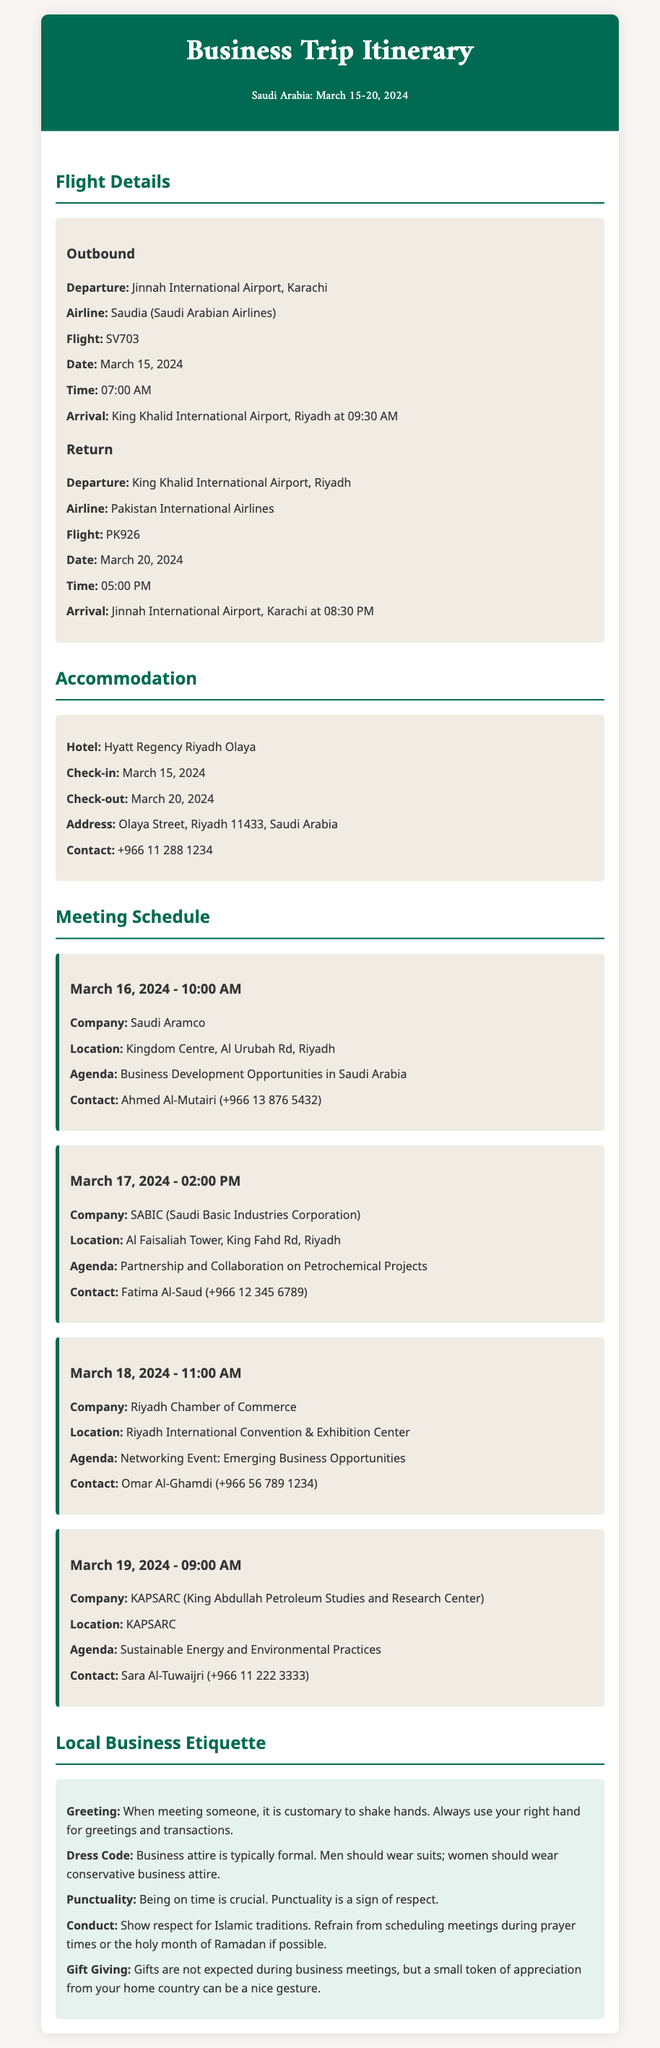What is the departure airport for the outbound flight? The departure airport is specified as Jinnah International Airport, Karachi in the flight details.
Answer: Jinnah International Airport, Karachi What is the check-in date for the accommodation? The check-in date is given under the accommodation section of the document.
Answer: March 15, 2024 Who is the contact person for the meeting with Saudi Aramco? The contact for the meeting is listed in the meeting schedule section under Saudi Aramco.
Answer: Ahmed Al-Mutairi (+966 13 876 5432) What company meeting is scheduled for March 18, 2024? The company meeting on this date is indicated in the meeting schedule section.
Answer: Riyadh Chamber of Commerce What is the dress code suggested in the local business etiquette? The information on dress code can be found in the local business etiquette guidelines of the document.
Answer: Formal business attire How many days will the trip last? The number of days can be calculated by the dates mentioned in the travel itinerary.
Answer: 6 days What is the agenda for the meeting with SABIC? The agenda is provided in the meeting details related to SABIC.
Answer: Partnership and Collaboration on Petrochemical Projects What is the airline for the return flight? The return flight details specify the airline in the flight information section.
Answer: Pakistan International Airlines 